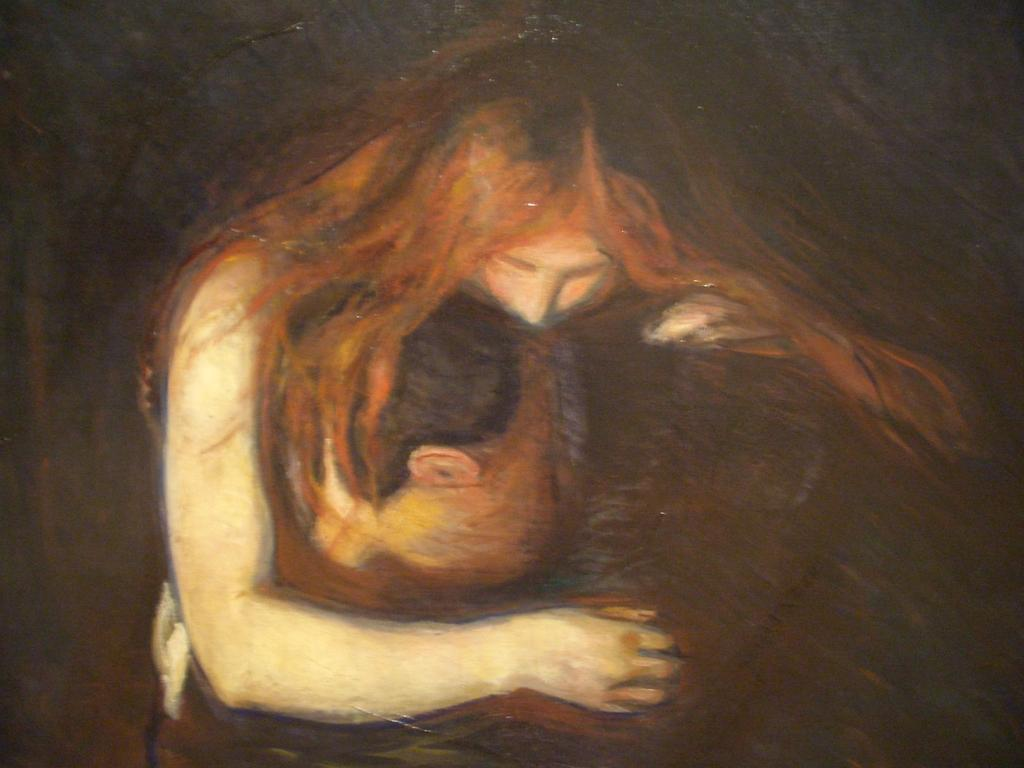What is the main subject of the image? There is a painting in the image. What is depicted in the painting? The painting depicts a girl and a boy. What is the boy doing in relation to the girl in the painting? The boy has his head placed on the lap of the girl. What channel is the giraffe watching in the image? There is no giraffe or television present in the image; it features a painting of a girl and a boy. How do the girl and the boy say good-bye to each other in the image? The image does not depict the girl and the boy saying good-bye; it only shows the boy resting his head on the girl's lap. 